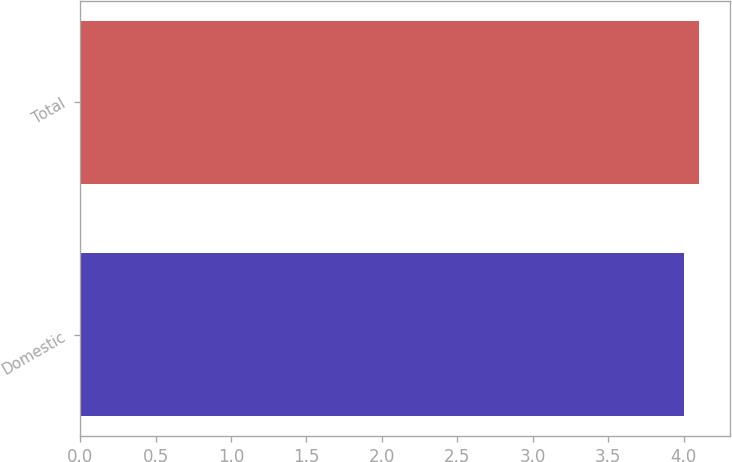Convert chart to OTSL. <chart><loc_0><loc_0><loc_500><loc_500><bar_chart><fcel>Domestic<fcel>Total<nl><fcel>4<fcel>4.1<nl></chart> 